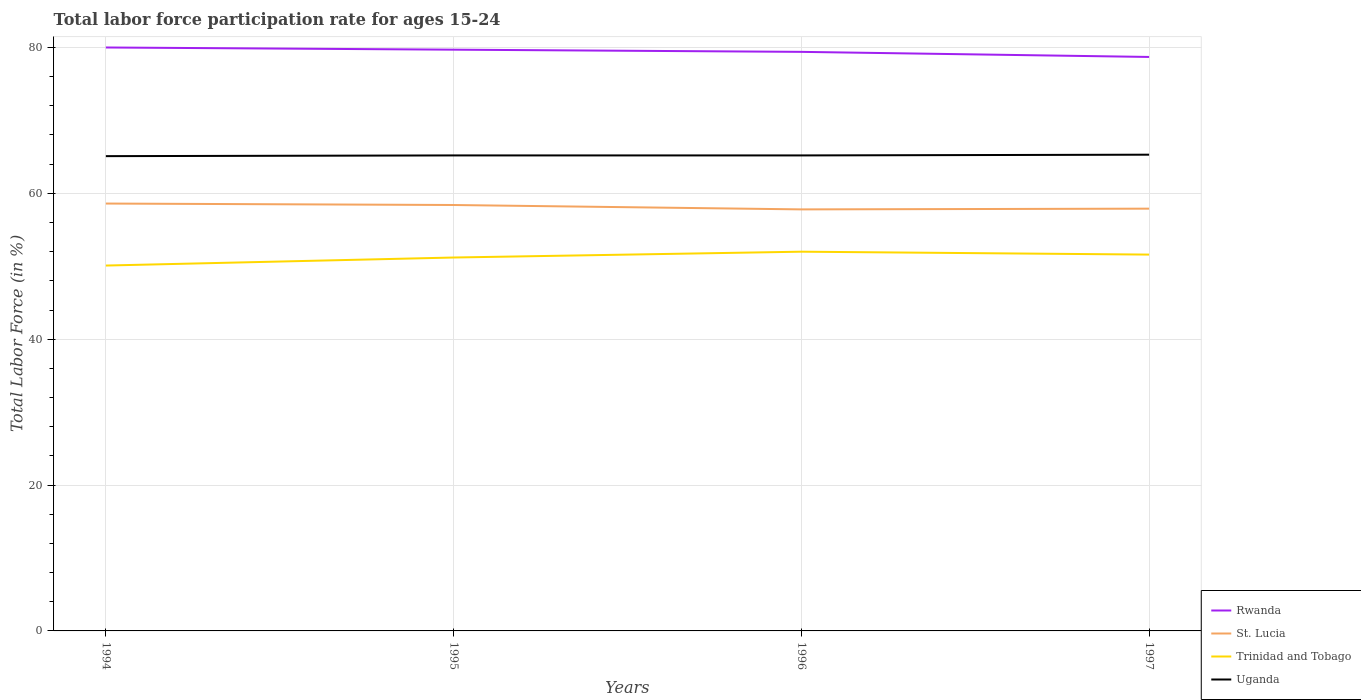Across all years, what is the maximum labor force participation rate in Uganda?
Offer a terse response. 65.1. What is the total labor force participation rate in Rwanda in the graph?
Give a very brief answer. 0.7. What is the difference between the highest and the second highest labor force participation rate in Uganda?
Your answer should be compact. 0.2. Is the labor force participation rate in Uganda strictly greater than the labor force participation rate in Rwanda over the years?
Give a very brief answer. Yes. How many lines are there?
Make the answer very short. 4. Does the graph contain any zero values?
Provide a short and direct response. No. Does the graph contain grids?
Ensure brevity in your answer.  Yes. What is the title of the graph?
Keep it short and to the point. Total labor force participation rate for ages 15-24. Does "Panama" appear as one of the legend labels in the graph?
Keep it short and to the point. No. What is the label or title of the X-axis?
Give a very brief answer. Years. What is the label or title of the Y-axis?
Offer a terse response. Total Labor Force (in %). What is the Total Labor Force (in %) in St. Lucia in 1994?
Keep it short and to the point. 58.6. What is the Total Labor Force (in %) in Trinidad and Tobago in 1994?
Provide a short and direct response. 50.1. What is the Total Labor Force (in %) in Uganda in 1994?
Keep it short and to the point. 65.1. What is the Total Labor Force (in %) of Rwanda in 1995?
Offer a terse response. 79.7. What is the Total Labor Force (in %) of St. Lucia in 1995?
Your response must be concise. 58.4. What is the Total Labor Force (in %) of Trinidad and Tobago in 1995?
Make the answer very short. 51.2. What is the Total Labor Force (in %) in Uganda in 1995?
Offer a very short reply. 65.2. What is the Total Labor Force (in %) in Rwanda in 1996?
Offer a terse response. 79.4. What is the Total Labor Force (in %) in St. Lucia in 1996?
Ensure brevity in your answer.  57.8. What is the Total Labor Force (in %) in Trinidad and Tobago in 1996?
Offer a very short reply. 52. What is the Total Labor Force (in %) of Uganda in 1996?
Provide a short and direct response. 65.2. What is the Total Labor Force (in %) of Rwanda in 1997?
Your answer should be very brief. 78.7. What is the Total Labor Force (in %) of St. Lucia in 1997?
Offer a terse response. 57.9. What is the Total Labor Force (in %) in Trinidad and Tobago in 1997?
Your answer should be very brief. 51.6. What is the Total Labor Force (in %) in Uganda in 1997?
Give a very brief answer. 65.3. Across all years, what is the maximum Total Labor Force (in %) of St. Lucia?
Provide a short and direct response. 58.6. Across all years, what is the maximum Total Labor Force (in %) in Trinidad and Tobago?
Give a very brief answer. 52. Across all years, what is the maximum Total Labor Force (in %) in Uganda?
Make the answer very short. 65.3. Across all years, what is the minimum Total Labor Force (in %) of Rwanda?
Provide a succinct answer. 78.7. Across all years, what is the minimum Total Labor Force (in %) of St. Lucia?
Provide a succinct answer. 57.8. Across all years, what is the minimum Total Labor Force (in %) of Trinidad and Tobago?
Your answer should be very brief. 50.1. Across all years, what is the minimum Total Labor Force (in %) in Uganda?
Your answer should be very brief. 65.1. What is the total Total Labor Force (in %) of Rwanda in the graph?
Provide a succinct answer. 317.8. What is the total Total Labor Force (in %) of St. Lucia in the graph?
Keep it short and to the point. 232.7. What is the total Total Labor Force (in %) of Trinidad and Tobago in the graph?
Your answer should be very brief. 204.9. What is the total Total Labor Force (in %) in Uganda in the graph?
Provide a short and direct response. 260.8. What is the difference between the Total Labor Force (in %) in Uganda in 1994 and that in 1996?
Ensure brevity in your answer.  -0.1. What is the difference between the Total Labor Force (in %) in St. Lucia in 1994 and that in 1997?
Your response must be concise. 0.7. What is the difference between the Total Labor Force (in %) of Trinidad and Tobago in 1994 and that in 1997?
Make the answer very short. -1.5. What is the difference between the Total Labor Force (in %) in Rwanda in 1995 and that in 1996?
Ensure brevity in your answer.  0.3. What is the difference between the Total Labor Force (in %) of St. Lucia in 1995 and that in 1996?
Provide a short and direct response. 0.6. What is the difference between the Total Labor Force (in %) of Trinidad and Tobago in 1995 and that in 1996?
Your answer should be very brief. -0.8. What is the difference between the Total Labor Force (in %) of Trinidad and Tobago in 1995 and that in 1997?
Make the answer very short. -0.4. What is the difference between the Total Labor Force (in %) in Uganda in 1995 and that in 1997?
Make the answer very short. -0.1. What is the difference between the Total Labor Force (in %) of Rwanda in 1994 and the Total Labor Force (in %) of St. Lucia in 1995?
Provide a succinct answer. 21.6. What is the difference between the Total Labor Force (in %) in Rwanda in 1994 and the Total Labor Force (in %) in Trinidad and Tobago in 1995?
Offer a terse response. 28.8. What is the difference between the Total Labor Force (in %) in Rwanda in 1994 and the Total Labor Force (in %) in Uganda in 1995?
Keep it short and to the point. 14.8. What is the difference between the Total Labor Force (in %) in Trinidad and Tobago in 1994 and the Total Labor Force (in %) in Uganda in 1995?
Provide a short and direct response. -15.1. What is the difference between the Total Labor Force (in %) in Rwanda in 1994 and the Total Labor Force (in %) in Uganda in 1996?
Give a very brief answer. 14.8. What is the difference between the Total Labor Force (in %) in St. Lucia in 1994 and the Total Labor Force (in %) in Trinidad and Tobago in 1996?
Provide a succinct answer. 6.6. What is the difference between the Total Labor Force (in %) of Trinidad and Tobago in 1994 and the Total Labor Force (in %) of Uganda in 1996?
Offer a very short reply. -15.1. What is the difference between the Total Labor Force (in %) of Rwanda in 1994 and the Total Labor Force (in %) of St. Lucia in 1997?
Provide a short and direct response. 22.1. What is the difference between the Total Labor Force (in %) in Rwanda in 1994 and the Total Labor Force (in %) in Trinidad and Tobago in 1997?
Your answer should be very brief. 28.4. What is the difference between the Total Labor Force (in %) in Rwanda in 1994 and the Total Labor Force (in %) in Uganda in 1997?
Make the answer very short. 14.7. What is the difference between the Total Labor Force (in %) in St. Lucia in 1994 and the Total Labor Force (in %) in Trinidad and Tobago in 1997?
Your response must be concise. 7. What is the difference between the Total Labor Force (in %) of St. Lucia in 1994 and the Total Labor Force (in %) of Uganda in 1997?
Make the answer very short. -6.7. What is the difference between the Total Labor Force (in %) in Trinidad and Tobago in 1994 and the Total Labor Force (in %) in Uganda in 1997?
Offer a terse response. -15.2. What is the difference between the Total Labor Force (in %) in Rwanda in 1995 and the Total Labor Force (in %) in St. Lucia in 1996?
Keep it short and to the point. 21.9. What is the difference between the Total Labor Force (in %) in Rwanda in 1995 and the Total Labor Force (in %) in Trinidad and Tobago in 1996?
Provide a short and direct response. 27.7. What is the difference between the Total Labor Force (in %) in Rwanda in 1995 and the Total Labor Force (in %) in Uganda in 1996?
Make the answer very short. 14.5. What is the difference between the Total Labor Force (in %) of St. Lucia in 1995 and the Total Labor Force (in %) of Trinidad and Tobago in 1996?
Offer a terse response. 6.4. What is the difference between the Total Labor Force (in %) of Trinidad and Tobago in 1995 and the Total Labor Force (in %) of Uganda in 1996?
Give a very brief answer. -14. What is the difference between the Total Labor Force (in %) of Rwanda in 1995 and the Total Labor Force (in %) of St. Lucia in 1997?
Your answer should be compact. 21.8. What is the difference between the Total Labor Force (in %) in Rwanda in 1995 and the Total Labor Force (in %) in Trinidad and Tobago in 1997?
Your answer should be compact. 28.1. What is the difference between the Total Labor Force (in %) of Rwanda in 1995 and the Total Labor Force (in %) of Uganda in 1997?
Provide a succinct answer. 14.4. What is the difference between the Total Labor Force (in %) in Trinidad and Tobago in 1995 and the Total Labor Force (in %) in Uganda in 1997?
Offer a terse response. -14.1. What is the difference between the Total Labor Force (in %) of Rwanda in 1996 and the Total Labor Force (in %) of St. Lucia in 1997?
Your answer should be compact. 21.5. What is the difference between the Total Labor Force (in %) in Rwanda in 1996 and the Total Labor Force (in %) in Trinidad and Tobago in 1997?
Give a very brief answer. 27.8. What is the difference between the Total Labor Force (in %) in St. Lucia in 1996 and the Total Labor Force (in %) in Uganda in 1997?
Make the answer very short. -7.5. What is the difference between the Total Labor Force (in %) of Trinidad and Tobago in 1996 and the Total Labor Force (in %) of Uganda in 1997?
Offer a very short reply. -13.3. What is the average Total Labor Force (in %) in Rwanda per year?
Provide a succinct answer. 79.45. What is the average Total Labor Force (in %) of St. Lucia per year?
Ensure brevity in your answer.  58.17. What is the average Total Labor Force (in %) in Trinidad and Tobago per year?
Your answer should be very brief. 51.23. What is the average Total Labor Force (in %) of Uganda per year?
Your answer should be compact. 65.2. In the year 1994, what is the difference between the Total Labor Force (in %) of Rwanda and Total Labor Force (in %) of St. Lucia?
Offer a very short reply. 21.4. In the year 1994, what is the difference between the Total Labor Force (in %) of Rwanda and Total Labor Force (in %) of Trinidad and Tobago?
Your response must be concise. 29.9. In the year 1994, what is the difference between the Total Labor Force (in %) of Rwanda and Total Labor Force (in %) of Uganda?
Provide a short and direct response. 14.9. In the year 1994, what is the difference between the Total Labor Force (in %) of St. Lucia and Total Labor Force (in %) of Trinidad and Tobago?
Make the answer very short. 8.5. In the year 1994, what is the difference between the Total Labor Force (in %) in Trinidad and Tobago and Total Labor Force (in %) in Uganda?
Your answer should be very brief. -15. In the year 1995, what is the difference between the Total Labor Force (in %) in Rwanda and Total Labor Force (in %) in St. Lucia?
Keep it short and to the point. 21.3. In the year 1995, what is the difference between the Total Labor Force (in %) of Rwanda and Total Labor Force (in %) of Trinidad and Tobago?
Your answer should be compact. 28.5. In the year 1995, what is the difference between the Total Labor Force (in %) in Rwanda and Total Labor Force (in %) in Uganda?
Provide a short and direct response. 14.5. In the year 1995, what is the difference between the Total Labor Force (in %) in St. Lucia and Total Labor Force (in %) in Uganda?
Ensure brevity in your answer.  -6.8. In the year 1996, what is the difference between the Total Labor Force (in %) of Rwanda and Total Labor Force (in %) of St. Lucia?
Make the answer very short. 21.6. In the year 1996, what is the difference between the Total Labor Force (in %) of Rwanda and Total Labor Force (in %) of Trinidad and Tobago?
Your response must be concise. 27.4. In the year 1996, what is the difference between the Total Labor Force (in %) of St. Lucia and Total Labor Force (in %) of Uganda?
Your answer should be compact. -7.4. In the year 1996, what is the difference between the Total Labor Force (in %) of Trinidad and Tobago and Total Labor Force (in %) of Uganda?
Provide a short and direct response. -13.2. In the year 1997, what is the difference between the Total Labor Force (in %) in Rwanda and Total Labor Force (in %) in St. Lucia?
Your response must be concise. 20.8. In the year 1997, what is the difference between the Total Labor Force (in %) of Rwanda and Total Labor Force (in %) of Trinidad and Tobago?
Your response must be concise. 27.1. In the year 1997, what is the difference between the Total Labor Force (in %) of St. Lucia and Total Labor Force (in %) of Trinidad and Tobago?
Provide a succinct answer. 6.3. In the year 1997, what is the difference between the Total Labor Force (in %) in St. Lucia and Total Labor Force (in %) in Uganda?
Make the answer very short. -7.4. In the year 1997, what is the difference between the Total Labor Force (in %) of Trinidad and Tobago and Total Labor Force (in %) of Uganda?
Your answer should be compact. -13.7. What is the ratio of the Total Labor Force (in %) in St. Lucia in 1994 to that in 1995?
Your answer should be very brief. 1. What is the ratio of the Total Labor Force (in %) in Trinidad and Tobago in 1994 to that in 1995?
Provide a succinct answer. 0.98. What is the ratio of the Total Labor Force (in %) in Uganda in 1994 to that in 1995?
Ensure brevity in your answer.  1. What is the ratio of the Total Labor Force (in %) in Rwanda in 1994 to that in 1996?
Give a very brief answer. 1.01. What is the ratio of the Total Labor Force (in %) of St. Lucia in 1994 to that in 1996?
Keep it short and to the point. 1.01. What is the ratio of the Total Labor Force (in %) of Trinidad and Tobago in 1994 to that in 1996?
Offer a very short reply. 0.96. What is the ratio of the Total Labor Force (in %) of Rwanda in 1994 to that in 1997?
Keep it short and to the point. 1.02. What is the ratio of the Total Labor Force (in %) of St. Lucia in 1994 to that in 1997?
Your response must be concise. 1.01. What is the ratio of the Total Labor Force (in %) of Trinidad and Tobago in 1994 to that in 1997?
Your answer should be compact. 0.97. What is the ratio of the Total Labor Force (in %) of St. Lucia in 1995 to that in 1996?
Your response must be concise. 1.01. What is the ratio of the Total Labor Force (in %) of Trinidad and Tobago in 1995 to that in 1996?
Ensure brevity in your answer.  0.98. What is the ratio of the Total Labor Force (in %) of Uganda in 1995 to that in 1996?
Offer a very short reply. 1. What is the ratio of the Total Labor Force (in %) of Rwanda in 1995 to that in 1997?
Offer a very short reply. 1.01. What is the ratio of the Total Labor Force (in %) in St. Lucia in 1995 to that in 1997?
Your response must be concise. 1.01. What is the ratio of the Total Labor Force (in %) in Rwanda in 1996 to that in 1997?
Ensure brevity in your answer.  1.01. What is the ratio of the Total Labor Force (in %) in Uganda in 1996 to that in 1997?
Make the answer very short. 1. What is the difference between the highest and the second highest Total Labor Force (in %) of St. Lucia?
Provide a succinct answer. 0.2. What is the difference between the highest and the second highest Total Labor Force (in %) in Trinidad and Tobago?
Provide a succinct answer. 0.4. What is the difference between the highest and the lowest Total Labor Force (in %) in St. Lucia?
Provide a succinct answer. 0.8. What is the difference between the highest and the lowest Total Labor Force (in %) of Trinidad and Tobago?
Offer a very short reply. 1.9. 